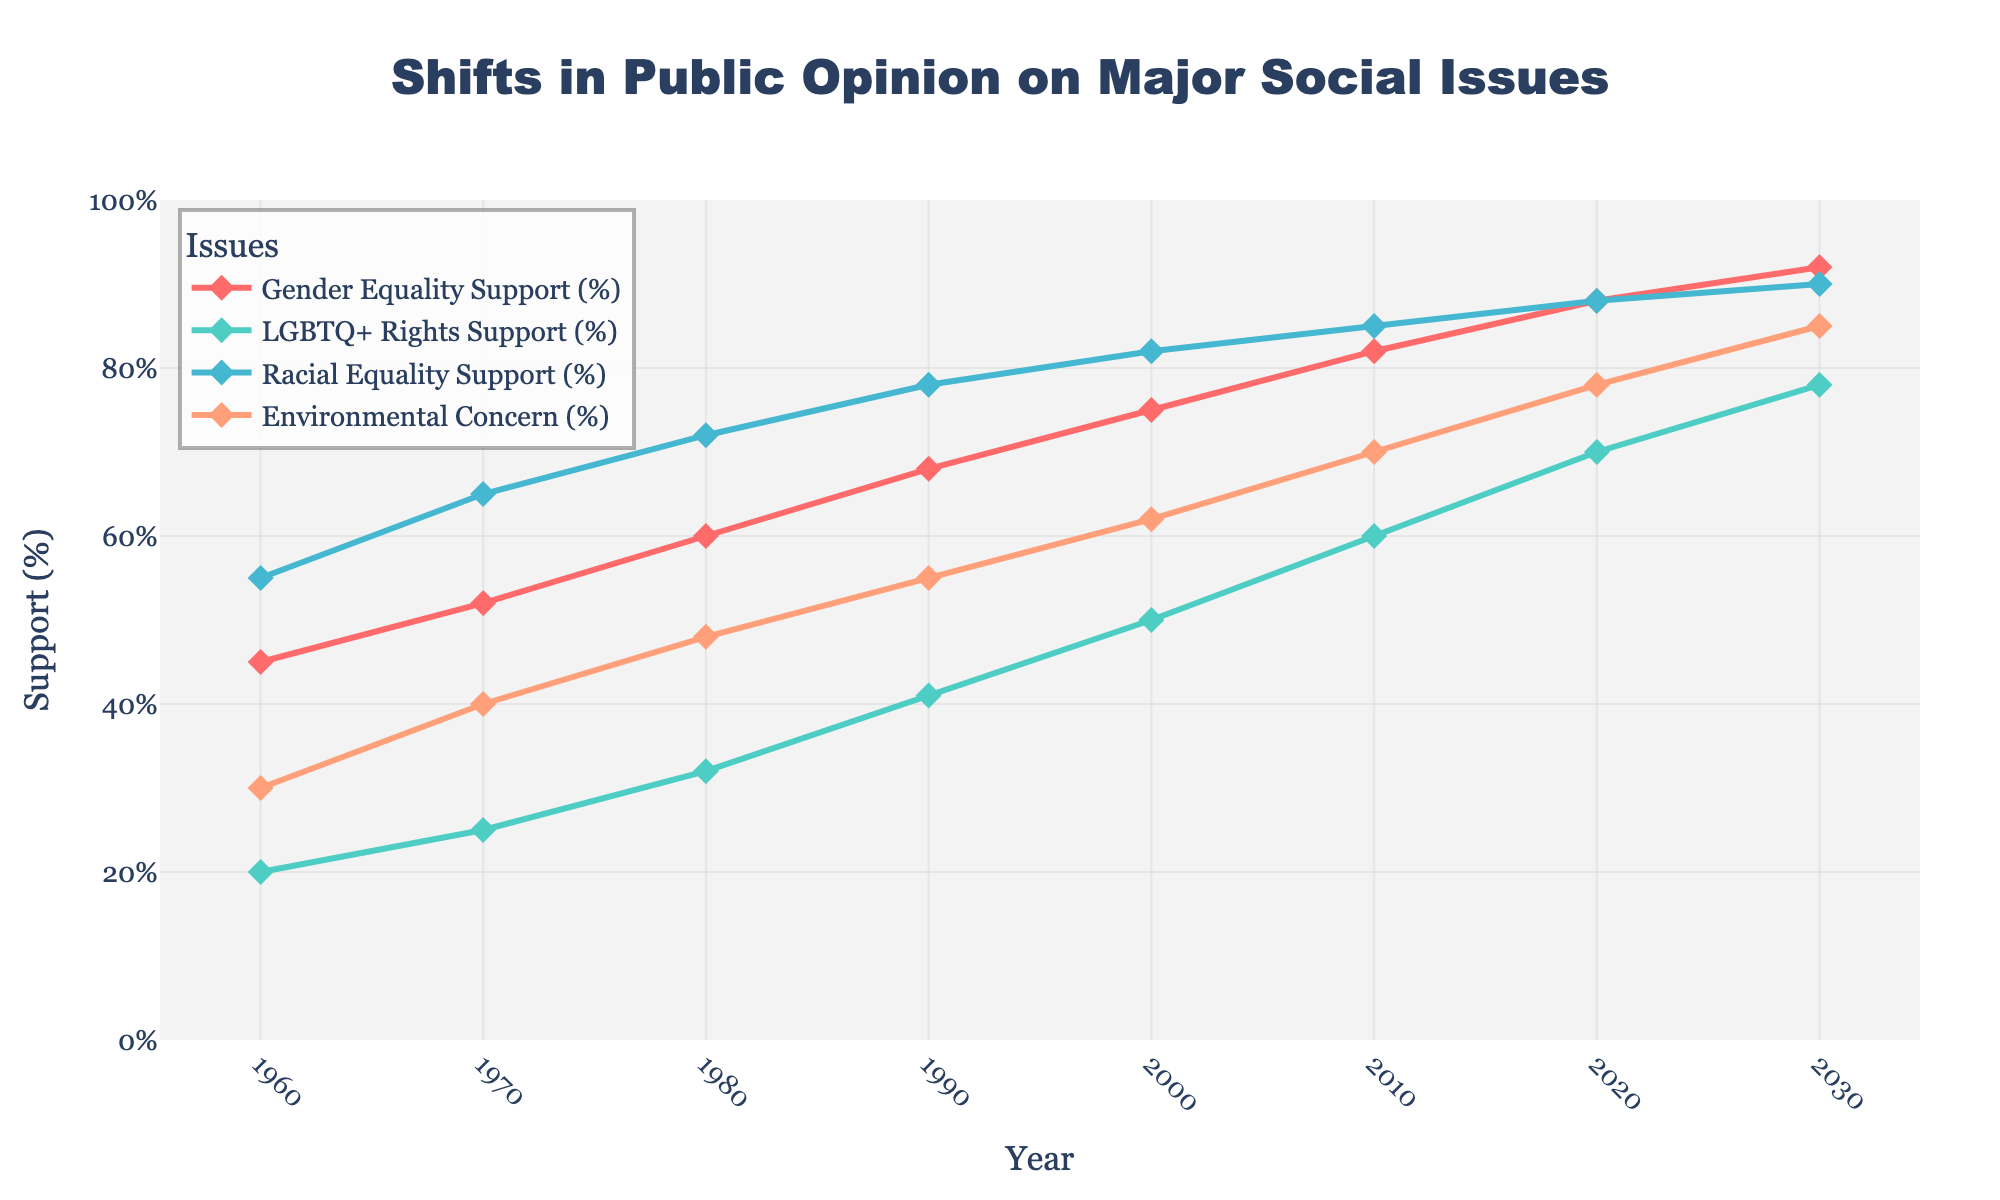What year shows equal support (88%) for both Gender Equality and Racial Equality? Notice that both lines for Gender Equality and Racial Equality intersect 88% in the year 2020. Therefore, the year with equal support for both issues is 2020.
Answer: 2020 Between 1960 and 2020, which issue demonstrates the most significant increase in support? Compare the percentages of each issue in 1960 and 2020 and calculate the difference: Gender Equality: 88 - 45 = 43%, LGBTQ+ Rights: 70 - 20 = 50%, Racial Equality: 88 - 55 = 33%, Environmental Concern: 78 - 30 = 48%. LGBTQ+ Rights shows the most significant increase with a difference of 50%.
Answer: LGBTQ+ Rights From the data, what is the average annual increase in support for LGBTQ+ Rights from 1960 to 2020? Calculate the total increase (70% - 20% = 50%) and divide this by the number of years (2020 - 1960 = 60). Average annual increase = 50% / 60 years ≈ 0.833% per year.
Answer: 0.833% per year How does the Environmental Concern trend compare to Gender Equality support between 2000 and 2020? Notice that Environmental Concern increases from 62% to 78% (a 16% increase), while Gender Equality increases from 75% to 88% (a 13% increase) between 2000 and 2020.
Answer: Environmental Concern increased more What is the sum of support percentages for Gender Equality and LGBTQ+ Rights in 2030? Add the support percentages for Gender Equality (92%) and LGBTQ+ Rights (78%) in 2030: 92 + 78 = 170%.
Answer: 170% Which issue had the smallest increase in support from 1960 to 1980? Calculate the increase for each issue from 1960 to 1980: Gender Equality: 60% - 45% = 15%, LGBTQ+ Rights: 32% - 20% = 12%, Racial Equality: 72% - 55% = 17%, Environmental Concern: 48% - 30% = 18%. LGBTQ+ Rights had the smallest increase of 12%.
Answer: LGBTQ+ Rights In what year did support for Gender Equality surpass 75%? Examine the data and identify the year when the support percentage for Gender Equality exceeds 75%. It first surpasses 75% in 2000.
Answer: 2000 